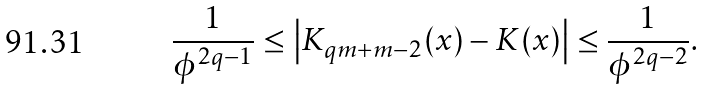Convert formula to latex. <formula><loc_0><loc_0><loc_500><loc_500>& \frac { 1 } { \phi ^ { 2 q - 1 } } \leq \left | K _ { q m + m - 2 } ( x ) - K ( x ) \right | \leq \frac { 1 } { \phi ^ { 2 q - 2 } } .</formula> 